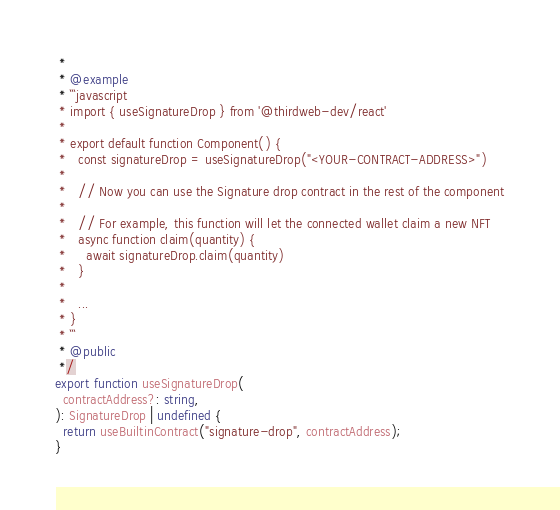Convert code to text. <code><loc_0><loc_0><loc_500><loc_500><_TypeScript_> *
 * @example
 * ```javascript
 * import { useSignatureDrop } from '@thirdweb-dev/react'
 *
 * export default function Component() {
 *   const signatureDrop = useSignatureDrop("<YOUR-CONTRACT-ADDRESS>")
 *
 *   // Now you can use the Signature drop contract in the rest of the component
 *
 *   // For example, this function will let the connected wallet claim a new NFT
 *   async function claim(quantity) {
 *     await signatureDrop.claim(quantity)
 *   }
 *
 *   ...
 * }
 * ```
 * @public
 */
export function useSignatureDrop(
  contractAddress?: string,
): SignatureDrop | undefined {
  return useBuiltinContract("signature-drop", contractAddress);
}
</code> 